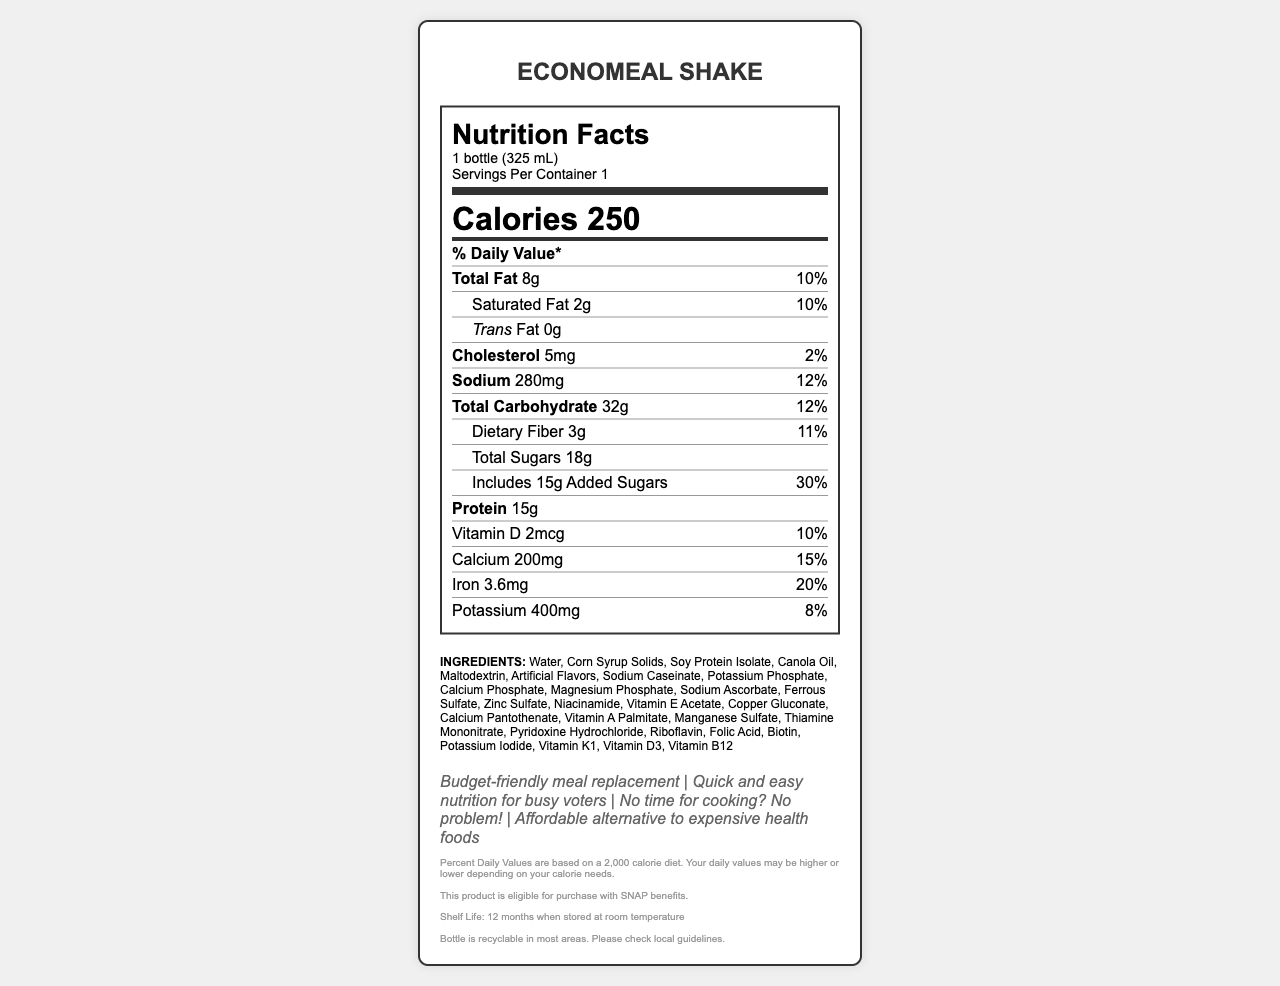what is the serving size of EconoMeal Shake? The serving size is listed at the beginning of the nutrition facts under the product name.
Answer: 1 bottle (325 mL) how many calories are in one serving of the EconoMeal Shake? The calorie content is mentioned prominently in the middle of the nutrition facts label.
Answer: 250 what is the total fat content and its percentage of daily value? The total fat content and percentage of daily value are listed under the nutrient section of the label.
Answer: 8g, 10% how much protein does the EconoMeal Shake contain? The amount of protein is listed under the nutrient section of the label.
Answer: 15g what are the main allergens in the EconoMeal Shake? The allergen information is provided near the bottom of the document.
Answer: Contains soy and milk. how much added sugar is in the EconoMeal Shake? The added sugar content and its daily value percentage are listed under the carbohydrate section.
Answer: 15g (30% daily value) what are the main ingredients listed in the EconoMeal Shake? The ingredients are listed towards the end of the document.
Answer: Water, Corn Syrup Solids, Soy Protein Isolate, Canola Oil, Maltodextrin, Artificial Flavors, Sodium Caseinate, Potassium Phosphate, Calcium Phosphate, Magnesium Phosphate, Sodium Ascorbate, Ferrous Sulfate, Zinc Sulfate, Niacinamide, Vitamin E Acetate, Copper Gluconate, Calcium Pantothenate, Vitamin A Palmitate, Manganese Sulfate, Thiamine Mononitrate, Pyridoxine Hydrochloride, Riboflavin, Folic Acid, Biotin, Potassium Iodide, Vitamin K1, Vitamin D3, Vitamin B12 what is the sodium content and its percentage of daily value? The sodium content and its percentage of daily value are listed under the nutrient section of the label.
Answer: 280mg, 12% can you buy this product with SNAP benefits? The document mentions that the product is eligible for purchase with SNAP benefits near the end.
Answer: Yes what is the shelf life of the EconoMeal Shake? The shelf life information is provided at the end of the document.
Answer: 12 months when stored at room temperature What is the manufacturer of the EconoMeal Shake? The manufacturer information is listed at the bottom of the document.
Answer: NutriCorp Industries How much iron does one serving of EconoMeal Shake provide? The iron content and its daily value percentage are listed under the nutrient section.
Answer: 3.6mg (20% daily value) Which of the following nutrients has the highest percentage of daily value? A. Vitamin D B. Calcium C. Iron Iron has a daily value of 20%, which is higher than Vitamin D and Calcium.
Answer: C. Iron Which of the following marketing claims is NOT mentioned for the EconoMeal Shake? I. Quick and easy nutrition II. Affordable alternative to expensive health foods III. Gluten-free The document lists several marketing claims, but "Gluten-free" is not one of them.
Answer: III. Gluten-free Is this product recyclable in most areas? The recyclability information mentioned that the bottle is recyclable in most areas, which is found near the end of the document.
Answer: Yes Summarize the nutritional value and claims of the EconoMeal Shake. The document details the nutritional composition, including calories, fats, proteins, carbohydrates, vitamins, and minerals, along with the marketing claims of being budget-friendly and convenient. It also includes allergen information, government subsidy eligibility, shelf life, and recyclability.
Answer: The EconoMeal Shake is a budget-friendly, processed meal replacement shake providing 250 calories per serving. It offers essential nutrients like proteins, vitamins, and minerals while being marketed as a quick, easy, and affordable nutritional option for low-income voters. What is the percentage of daily value for Vitamin E in the EconoMeal Shake? The document does not provide the daily value percentage for Vitamin E; it only lists the vitamin categories where applicable.
Answer: Not enough information 